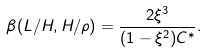Convert formula to latex. <formula><loc_0><loc_0><loc_500><loc_500>\beta ( L / H , H / \rho ) = \frac { 2 \xi ^ { 3 } } { ( 1 - \xi ^ { 2 } ) C ^ { * } } .</formula> 